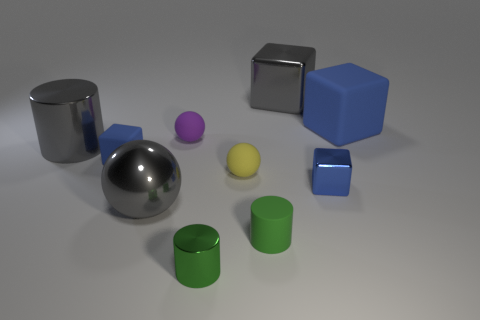How many metallic things are either purple spheres or yellow things?
Your answer should be very brief. 0. Do the green thing on the left side of the tiny yellow sphere and the gray object that is right of the tiny metallic cylinder have the same shape?
Keep it short and to the point. No. Are there any big spheres that have the same material as the yellow thing?
Your answer should be very brief. No. What color is the big cylinder?
Offer a terse response. Gray. There is a shiny cube that is to the left of the blue metallic block; what is its size?
Give a very brief answer. Large. What number of metal spheres have the same color as the large shiny block?
Provide a succinct answer. 1. Is there a big gray shiny sphere that is behind the rubber object that is behind the purple object?
Your answer should be very brief. No. There is a tiny shiny object right of the small yellow sphere; does it have the same color as the matte block that is to the right of the purple sphere?
Provide a short and direct response. Yes. There is a metallic block that is the same size as the yellow thing; what color is it?
Provide a succinct answer. Blue. Is the number of big blue cubes on the left side of the big rubber cube the same as the number of cylinders that are on the left side of the tiny yellow matte sphere?
Your response must be concise. No. 